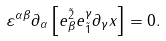Convert formula to latex. <formula><loc_0><loc_0><loc_500><loc_500>\varepsilon ^ { \alpha \beta } \partial _ { \alpha } \left [ e _ { \beta } ^ { \tilde { 2 } } e _ { \tilde { 1 } } ^ { \gamma } \partial _ { \gamma } x \right ] = 0 .</formula> 